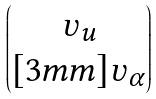Convert formula to latex. <formula><loc_0><loc_0><loc_500><loc_500>\begin{pmatrix} \upsilon _ { u } \\ [ 3 m m ] \upsilon _ { \alpha } \end{pmatrix}</formula> 